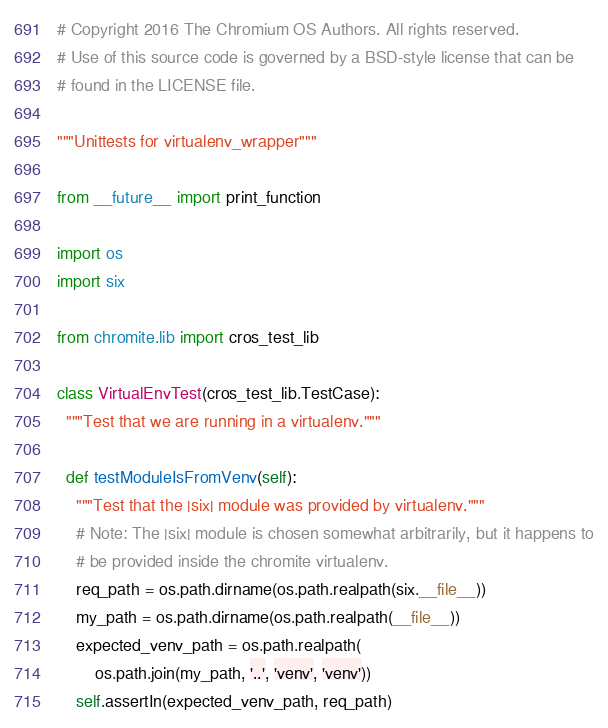Convert code to text. <code><loc_0><loc_0><loc_500><loc_500><_Python_># Copyright 2016 The Chromium OS Authors. All rights reserved.
# Use of this source code is governed by a BSD-style license that can be
# found in the LICENSE file.

"""Unittests for virtualenv_wrapper"""

from __future__ import print_function

import os
import six

from chromite.lib import cros_test_lib

class VirtualEnvTest(cros_test_lib.TestCase):
  """Test that we are running in a virtualenv."""

  def testModuleIsFromVenv(self):
    """Test that the |six| module was provided by virtualenv."""
    # Note: The |six| module is chosen somewhat arbitrarily, but it happens to
    # be provided inside the chromite virtualenv.
    req_path = os.path.dirname(os.path.realpath(six.__file__))
    my_path = os.path.dirname(os.path.realpath(__file__))
    expected_venv_path = os.path.realpath(
        os.path.join(my_path, '..', 'venv', 'venv'))
    self.assertIn(expected_venv_path, req_path)
</code> 